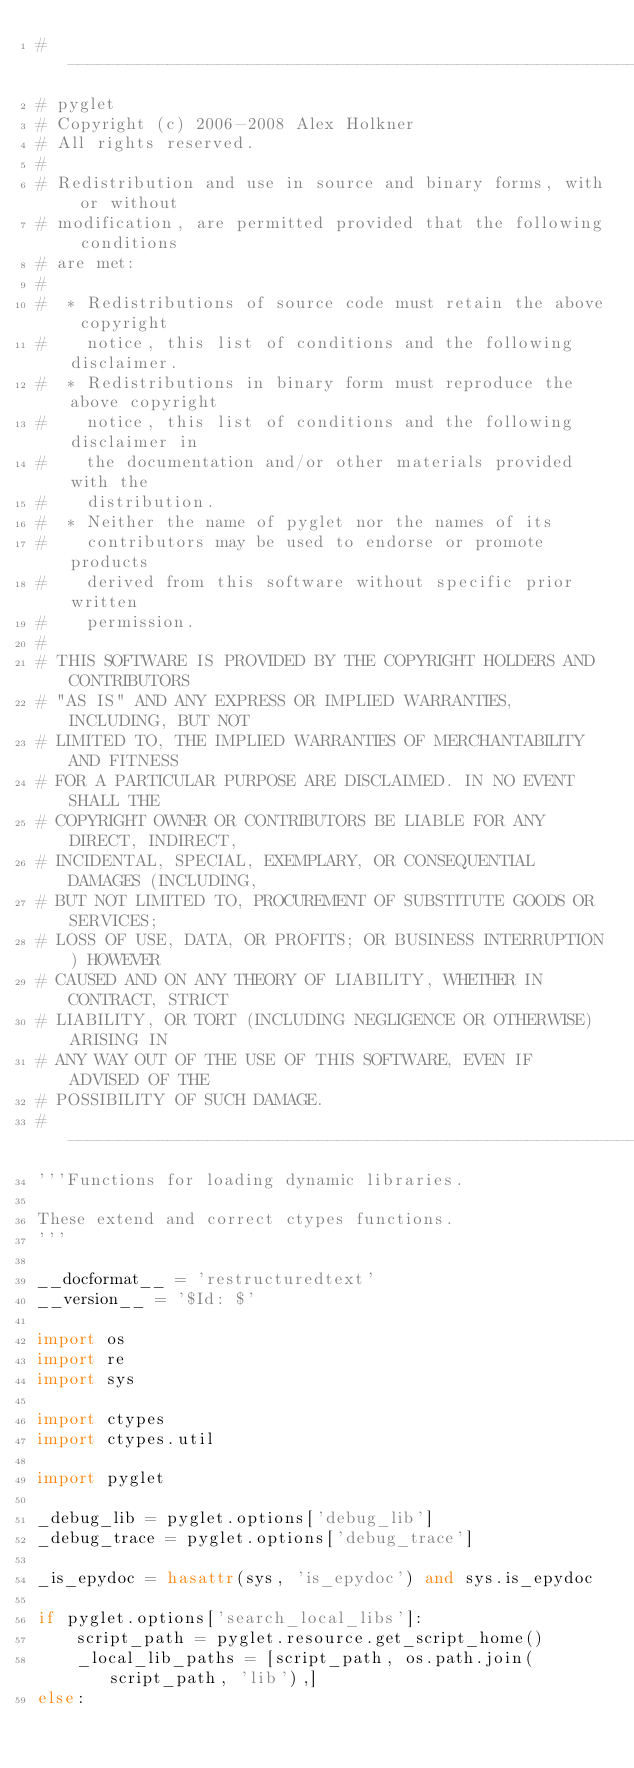Convert code to text. <code><loc_0><loc_0><loc_500><loc_500><_Python_># ----------------------------------------------------------------------------
# pyglet
# Copyright (c) 2006-2008 Alex Holkner
# All rights reserved.
# 
# Redistribution and use in source and binary forms, with or without
# modification, are permitted provided that the following conditions 
# are met:
#
#  * Redistributions of source code must retain the above copyright
#    notice, this list of conditions and the following disclaimer.
#  * Redistributions in binary form must reproduce the above copyright 
#    notice, this list of conditions and the following disclaimer in
#    the documentation and/or other materials provided with the
#    distribution.
#  * Neither the name of pyglet nor the names of its
#    contributors may be used to endorse or promote products
#    derived from this software without specific prior written
#    permission.
#
# THIS SOFTWARE IS PROVIDED BY THE COPYRIGHT HOLDERS AND CONTRIBUTORS
# "AS IS" AND ANY EXPRESS OR IMPLIED WARRANTIES, INCLUDING, BUT NOT
# LIMITED TO, THE IMPLIED WARRANTIES OF MERCHANTABILITY AND FITNESS
# FOR A PARTICULAR PURPOSE ARE DISCLAIMED. IN NO EVENT SHALL THE
# COPYRIGHT OWNER OR CONTRIBUTORS BE LIABLE FOR ANY DIRECT, INDIRECT,
# INCIDENTAL, SPECIAL, EXEMPLARY, OR CONSEQUENTIAL DAMAGES (INCLUDING,
# BUT NOT LIMITED TO, PROCUREMENT OF SUBSTITUTE GOODS OR SERVICES;
# LOSS OF USE, DATA, OR PROFITS; OR BUSINESS INTERRUPTION) HOWEVER
# CAUSED AND ON ANY THEORY OF LIABILITY, WHETHER IN CONTRACT, STRICT
# LIABILITY, OR TORT (INCLUDING NEGLIGENCE OR OTHERWISE) ARISING IN
# ANY WAY OUT OF THE USE OF THIS SOFTWARE, EVEN IF ADVISED OF THE
# POSSIBILITY OF SUCH DAMAGE.
# ----------------------------------------------------------------------------
'''Functions for loading dynamic libraries.

These extend and correct ctypes functions.
'''

__docformat__ = 'restructuredtext'
__version__ = '$Id: $'

import os
import re
import sys

import ctypes
import ctypes.util

import pyglet

_debug_lib = pyglet.options['debug_lib']
_debug_trace = pyglet.options['debug_trace']

_is_epydoc = hasattr(sys, 'is_epydoc') and sys.is_epydoc

if pyglet.options['search_local_libs']:
    script_path = pyglet.resource.get_script_home()
    _local_lib_paths = [script_path, os.path.join(script_path, 'lib'),]
else:</code> 